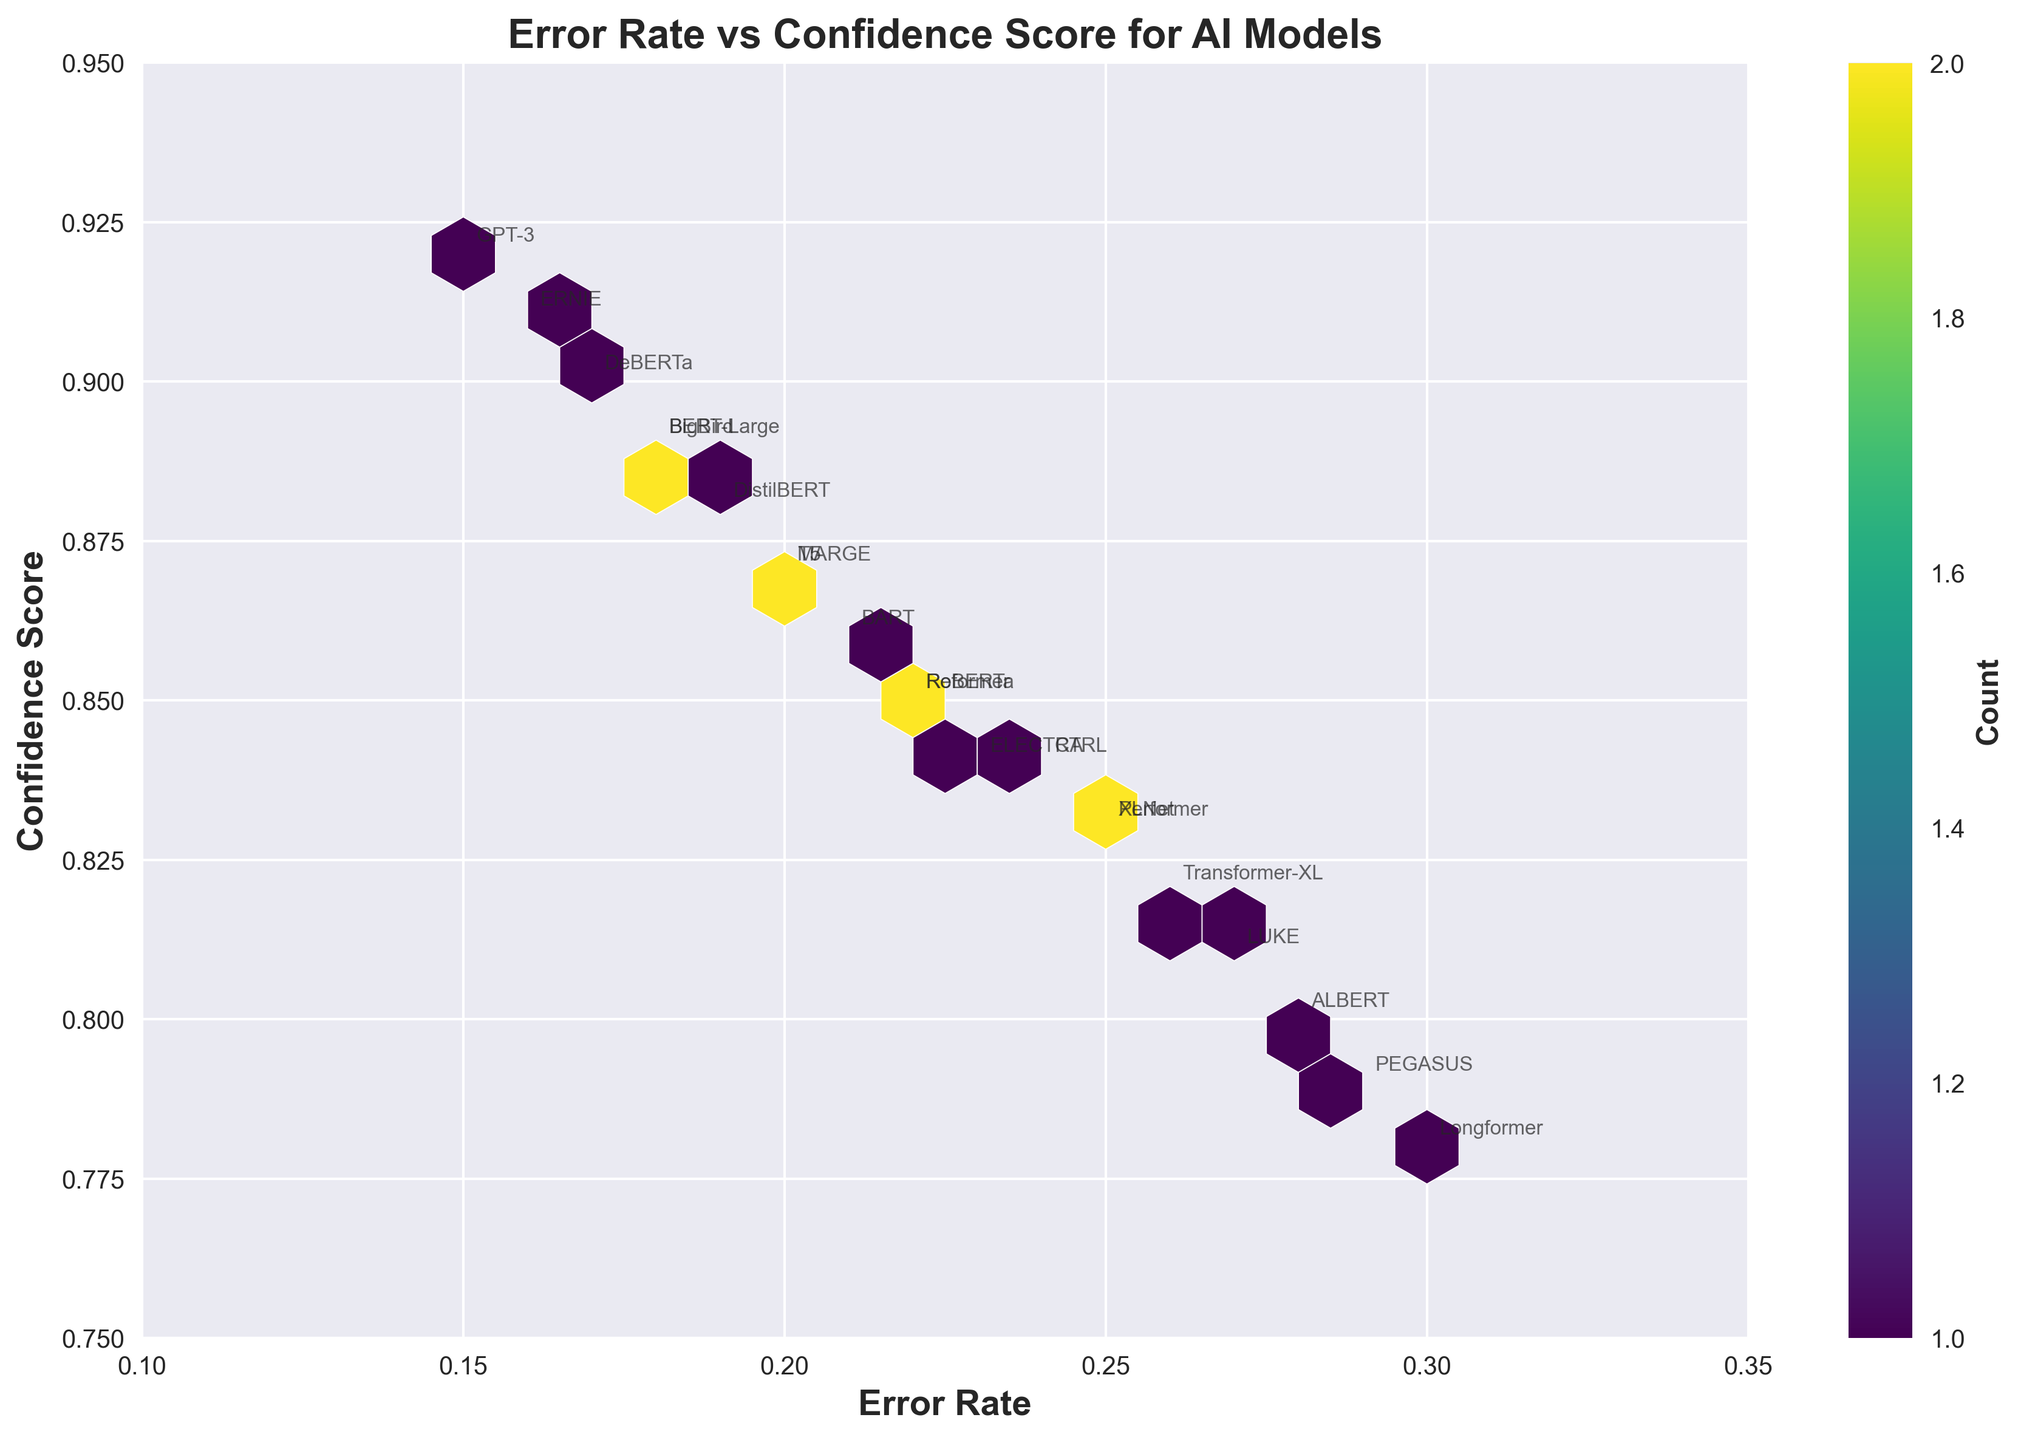What is the title of the figure? The title of the figure is usually located at the top center, and in this case, it reads "Error Rate vs Confidence Score for AI Models".
Answer: Error Rate vs Confidence Score for AI Models Which axes represent the error rate and confidence score? The x-axis represents the error rate, and the y-axis represents the confidence score. This is indicated by the labels "Error Rate" on the horizontal axis and "Confidence Score" on the vertical axis.
Answer: x-axis: Error Rate, y-axis: Confidence Score How many data points appear to be within an error rate range of 0.15 to 0.20? By examining the hexagonal bins, we need to count the number of entries within the range 0.15 to 0.20 on the x-axis. There are 6 data points in this range based on the hexbin counts.
Answer: 6 Which model has the highest confidence score? To determine this, we look for the data point with the highest location on the y-axis. ERNIE has the highest confidence score of 0.91 as annotated next to the respective point.
Answer: ERNIE What is the error rate and confidence score of the model Longformer? Locate the annotation for "Longformer" on the chart. It corresponds to an error rate of 0.30 and a confidence score of 0.78.
Answer: Error rate: 0.30, Confidence score: 0.78 Between GPT-3 and XLNet, which model has a lower error rate, and what are their respective error rates? Compare the error rates of GPT-3 and XLNet. GPT-3 has an error rate of 0.15, while XLNet has an error rate of 0.25. Therefore, GPT-3 has a lower error rate.
Answer: GPT-3: 0.15, XLNet: 0.25 How many models have an error rate greater than 0.25 and a confidence score less than 0.85? By examining the annotated data points, models that meet these criteria are LUKE, PEGASUS, and Longformer, totaling 3 models.
Answer: 3 Which model within an error rate range of 0.20 to 0.25 has the highest confidence score? Within the range of 0.20 to 0.25 on the x-axis, the models are T5, BART, Reformer, and Performer. Of these, T5 has the highest confidence score of 0.87.
Answer: T5 What is the granularity (grid size) of the hexagons in the plot? The gridsize parameter in the plot's code determines this. The plot uses 15 as the gridsize, meaning the figure is divided into 15 bins in each dimension.
Answer: 15 